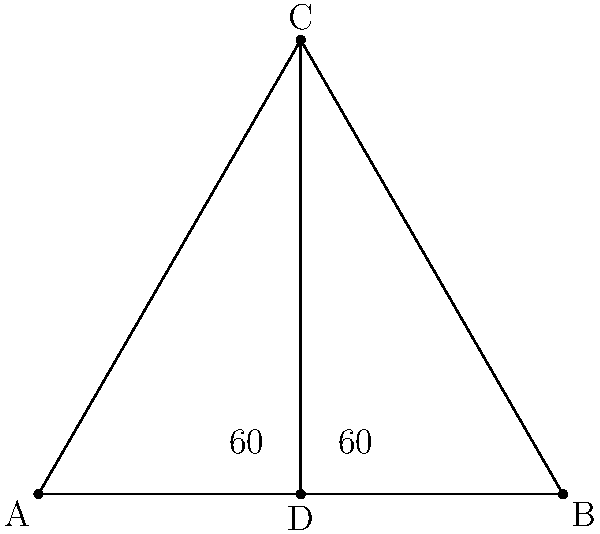The Tsing Ma Bridge in Hong Kong is known for its impressive suspension design. If we simplify its main structural elements into a triangular shape, as shown in the diagram, what is the measure of angle ACD? To find the measure of angle ACD, let's follow these steps:

1) First, we need to recognize that the diagram shows an equilateral triangle ABC. This is because:
   - The base angles are both labeled as 60°
   - In an equilateral triangle, all angles are equal and measure 60°

2) Point D is the midpoint of side AB, creating two right triangles: ACD and BCD.

3) In right triangle ACD:
   - We know that angle CAD is 60° (base angle of the equilateral triangle)
   - We know that angle ACD is a right angle (90°), as D is the midpoint of AB

4) The sum of angles in a triangle is always 180°. So we can find angle ACD:
   
   $$180° = 60° + 90° + \angle ACD$$
   
   $$\angle ACD = 180° - 60° - 90° = 30°$$

Therefore, the measure of angle ACD is 30°.
Answer: 30° 